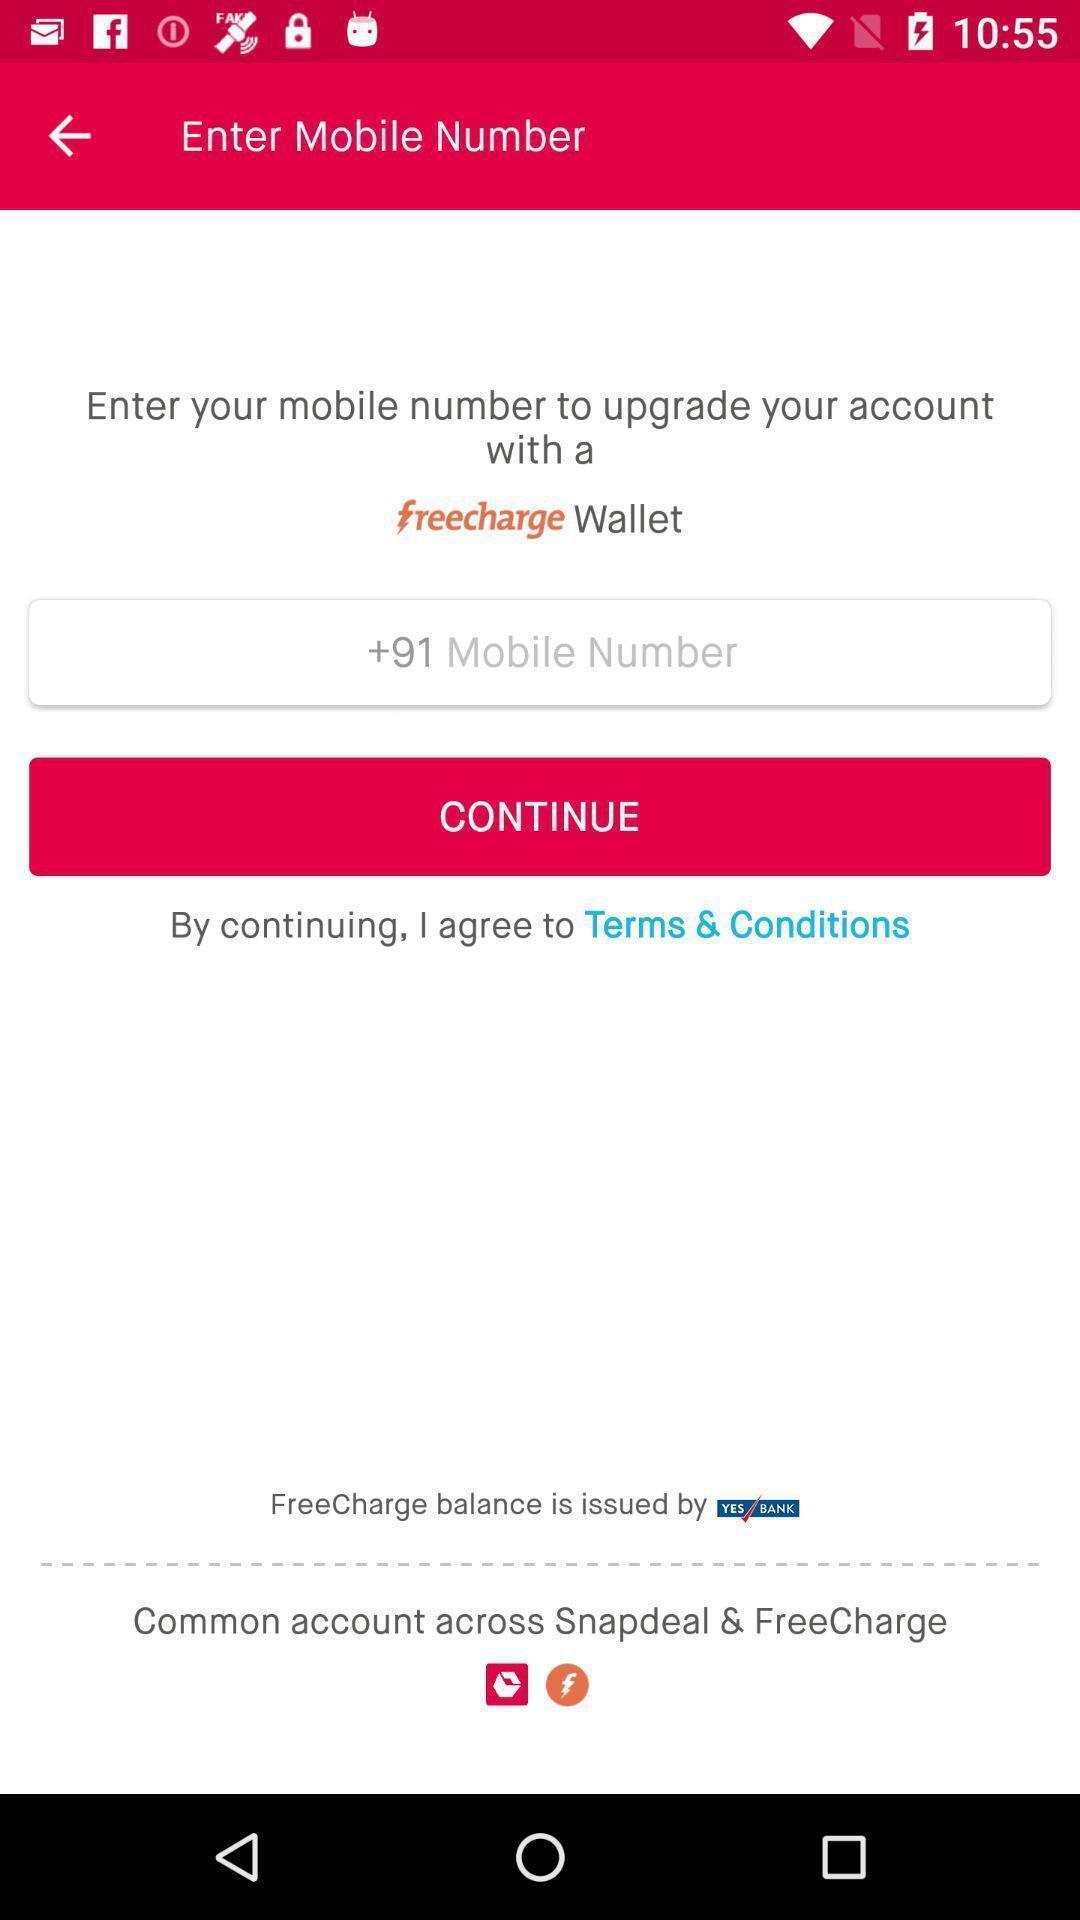Describe the key features of this screenshot. Welcome page. 